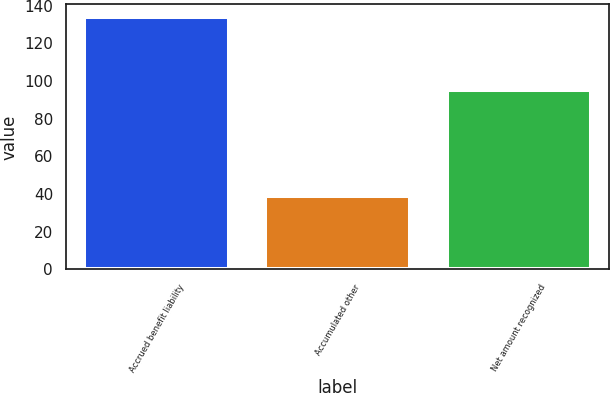Convert chart. <chart><loc_0><loc_0><loc_500><loc_500><bar_chart><fcel>Accrued benefit liability<fcel>Accumulated other<fcel>Net amount recognized<nl><fcel>134<fcel>39<fcel>95<nl></chart> 